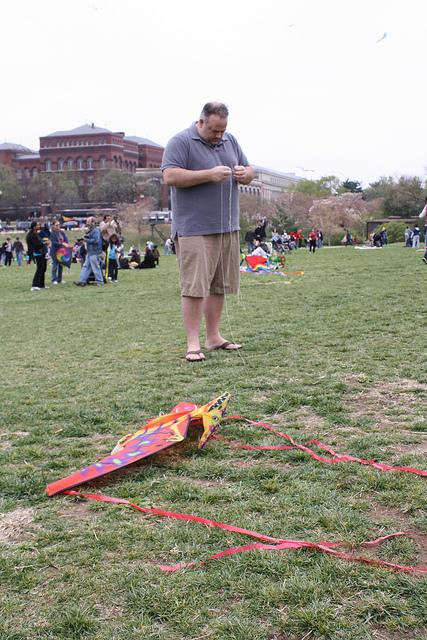What is the red object on the ground capable of? flying 